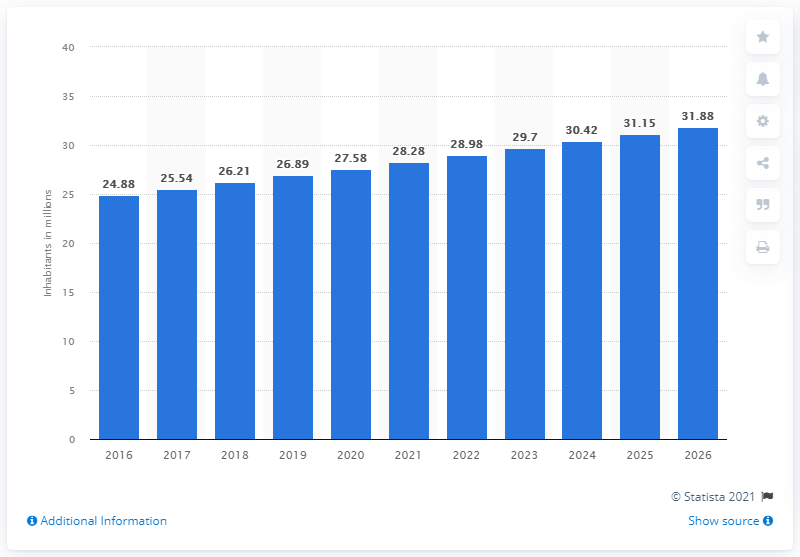Identify some key points in this picture. As of 2020, the population of Madagascar was approximately 27.58 million people. 